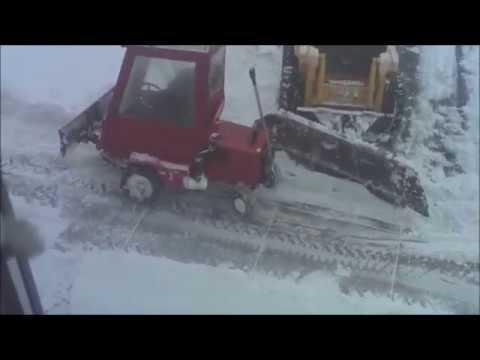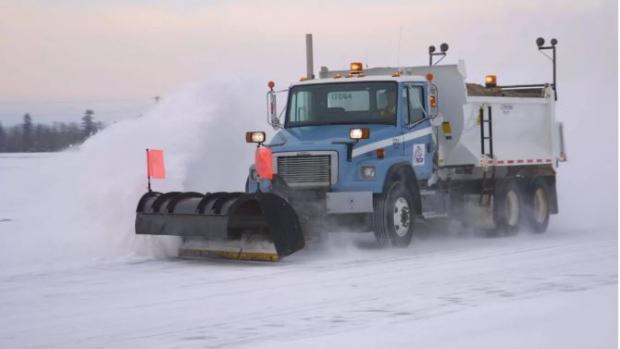The first image is the image on the left, the second image is the image on the right. Evaluate the accuracy of this statement regarding the images: "Right image includes a camera-facing plow truck driving toward a curve in a snowy road scene.". Is it true? Answer yes or no. No. The first image is the image on the left, the second image is the image on the right. Evaluate the accuracy of this statement regarding the images: "In one of the images, a red vehicle is pushing and clearing snow.". Is it true? Answer yes or no. Yes. 